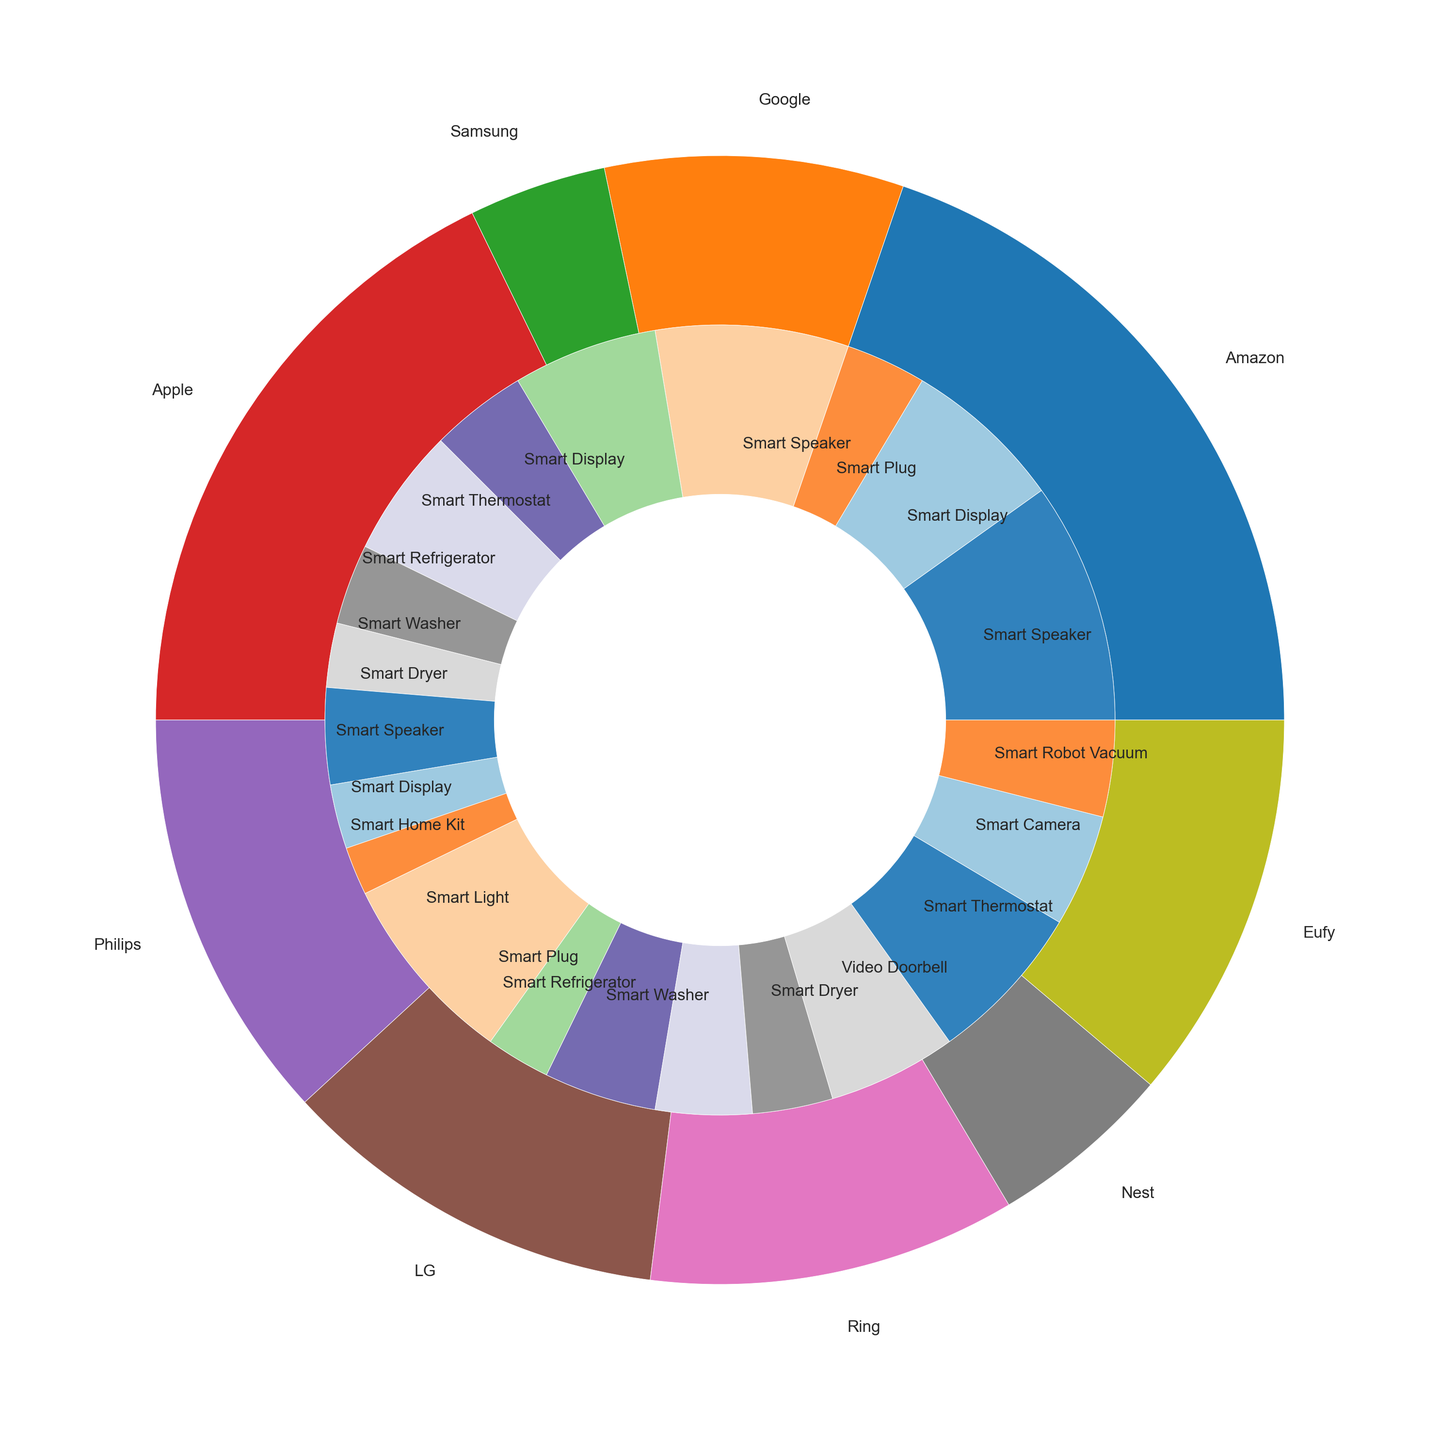Which brand has the largest overall market share? To identify the brand with the largest market share, look at the outer pie chart and compare the segments. The largest segment visually represents the brand with the highest share.
Answer: Amazon What is the combined market share of smart refrigerators and smart washers? Locate the segments for smart refrigerators and smart washers in the inner pie chart. Add their market shares: Samsung (8 for refrigerator + 5 for washer) + LG (7 for refrigerator + 6 for washer) = 26
Answer: 26 How does the market share of Google's smart displays compare to Apple's smart displays? Find the inner pie chart segments for Google's and Apple's smart displays. Compare their market shares: Google (9) and Apple (4). Google has the higher share.
Answer: Google has a higher share What percentage of the total smart home device market is held by Amazon's smart speakers? Amazon's smart speaker segment in the inner pie chart is 15. To find the percentage, we need the total market share sum, which is 135. Then, (15 / 135) * 100 = 11.1%.
Answer: 11.1% Which device type has the smallest market share and what is the share? Identify the smallest segment in the inner pie chart and note its label. The smallest segment is Apple's Smart Home Kit with a market share of 3.
Answer: Smart Home Kit, 3 Compare the market share of Philips smart lights with the combined market share of LG smart washers and dryers. Philips' smart lights have a share of 12. LG's smart washers and dryers together have 6 + 5 = 11. Compare these sums: Philips' 12 is greater than LG's 11.
Answer: Philips' is greater What is the total market share for smart speakers? Add the market shares of smart speakers from Amazon (15), Google (12), and Apple (6). The total is 15 + 12 + 6 = 33.
Answer: 33 Which color represents Samsung’s devices, and what are the device types included? Identify Samsung's segment in the outer pie chart and note the color. Samsung's devices, indicated by a particular color, include Smart Refrigerator, Smart Washer, and Smart Dryer.
Answer: (Color of Samsung), Smart Refrigerator, Smart Washer, Smart Dryer How does the market share of Ring video doorbells compare to Nest smart cameras? Look up the market shares of Ring video doorbells (8) and Nest smart cameras (7). Ring video doorbells have a slightly higher share than Nest smart cameras.
Answer: Ring has a slightly higher share What is the difference in market share between Amazon’s smart displays and smart plugs? Amazon’s smart displays have a market share of 10, and smart plugs have 5. The difference is calculated as 10 - 5 = 5.
Answer: 5 